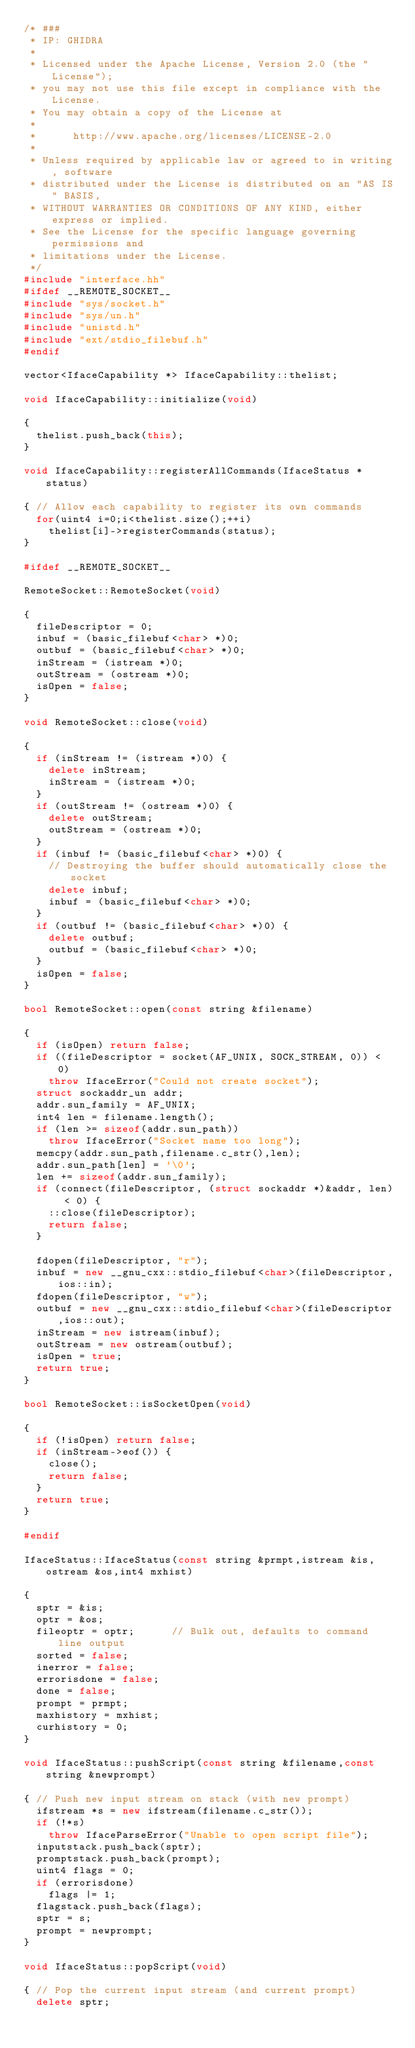Convert code to text. <code><loc_0><loc_0><loc_500><loc_500><_C++_>/* ###
 * IP: GHIDRA
 *
 * Licensed under the Apache License, Version 2.0 (the "License");
 * you may not use this file except in compliance with the License.
 * You may obtain a copy of the License at
 * 
 *      http://www.apache.org/licenses/LICENSE-2.0
 * 
 * Unless required by applicable law or agreed to in writing, software
 * distributed under the License is distributed on an "AS IS" BASIS,
 * WITHOUT WARRANTIES OR CONDITIONS OF ANY KIND, either express or implied.
 * See the License for the specific language governing permissions and
 * limitations under the License.
 */
#include "interface.hh"
#ifdef __REMOTE_SOCKET__
#include "sys/socket.h"
#include "sys/un.h"
#include "unistd.h"
#include "ext/stdio_filebuf.h"
#endif

vector<IfaceCapability *> IfaceCapability::thelist;

void IfaceCapability::initialize(void)

{
  thelist.push_back(this);
}

void IfaceCapability::registerAllCommands(IfaceStatus *status)

{ // Allow each capability to register its own commands
  for(uint4 i=0;i<thelist.size();++i)
    thelist[i]->registerCommands(status);
}

#ifdef __REMOTE_SOCKET__

RemoteSocket::RemoteSocket(void)

{
  fileDescriptor = 0;
  inbuf = (basic_filebuf<char> *)0;
  outbuf = (basic_filebuf<char> *)0;
  inStream = (istream *)0;
  outStream = (ostream *)0;
  isOpen = false;
}

void RemoteSocket::close(void)

{
  if (inStream != (istream *)0) {
    delete inStream;
    inStream = (istream *)0;
  }
  if (outStream != (ostream *)0) {
    delete outStream;
    outStream = (ostream *)0;
  }
  if (inbuf != (basic_filebuf<char> *)0) {
    // Destroying the buffer should automatically close the socket
    delete inbuf;
    inbuf = (basic_filebuf<char> *)0;
  }
  if (outbuf != (basic_filebuf<char> *)0) {
    delete outbuf;
    outbuf = (basic_filebuf<char> *)0;
  }
  isOpen = false;
}

bool RemoteSocket::open(const string &filename)

{
  if (isOpen) return false;
  if ((fileDescriptor = socket(AF_UNIX, SOCK_STREAM, 0)) < 0)
    throw IfaceError("Could not create socket");
  struct sockaddr_un addr;
  addr.sun_family = AF_UNIX;
  int4 len = filename.length();
  if (len >= sizeof(addr.sun_path))
    throw IfaceError("Socket name too long");
  memcpy(addr.sun_path,filename.c_str(),len);
  addr.sun_path[len] = '\0';
  len += sizeof(addr.sun_family);
  if (connect(fileDescriptor, (struct sockaddr *)&addr, len) < 0) {
    ::close(fileDescriptor);
    return false;
  }

  fdopen(fileDescriptor, "r");
  inbuf = new __gnu_cxx::stdio_filebuf<char>(fileDescriptor,ios::in);
  fdopen(fileDescriptor, "w");
  outbuf = new __gnu_cxx::stdio_filebuf<char>(fileDescriptor,ios::out);
  inStream = new istream(inbuf);
  outStream = new ostream(outbuf);
  isOpen = true;
  return true;
}

bool RemoteSocket::isSocketOpen(void)

{
  if (!isOpen) return false;
  if (inStream->eof()) {
    close();
    return false;
  }
  return true;
}

#endif

IfaceStatus::IfaceStatus(const string &prmpt,istream &is,ostream &os,int4 mxhist)

{
  sptr = &is;
  optr = &os;
  fileoptr = optr;		// Bulk out, defaults to command line output
  sorted = false;
  inerror = false;
  errorisdone = false;
  done = false;
  prompt = prmpt;
  maxhistory = mxhist;
  curhistory = 0;
}

void IfaceStatus::pushScript(const string &filename,const string &newprompt)

{ // Push new input stream on stack (with new prompt)
  ifstream *s = new ifstream(filename.c_str());
  if (!*s)
    throw IfaceParseError("Unable to open script file");
  inputstack.push_back(sptr);
  promptstack.push_back(prompt);
  uint4 flags = 0;
  if (errorisdone)
    flags |= 1;
  flagstack.push_back(flags);
  sptr = s;
  prompt = newprompt;
}

void IfaceStatus::popScript(void)

{ // Pop the current input stream (and current prompt)
  delete sptr;</code> 